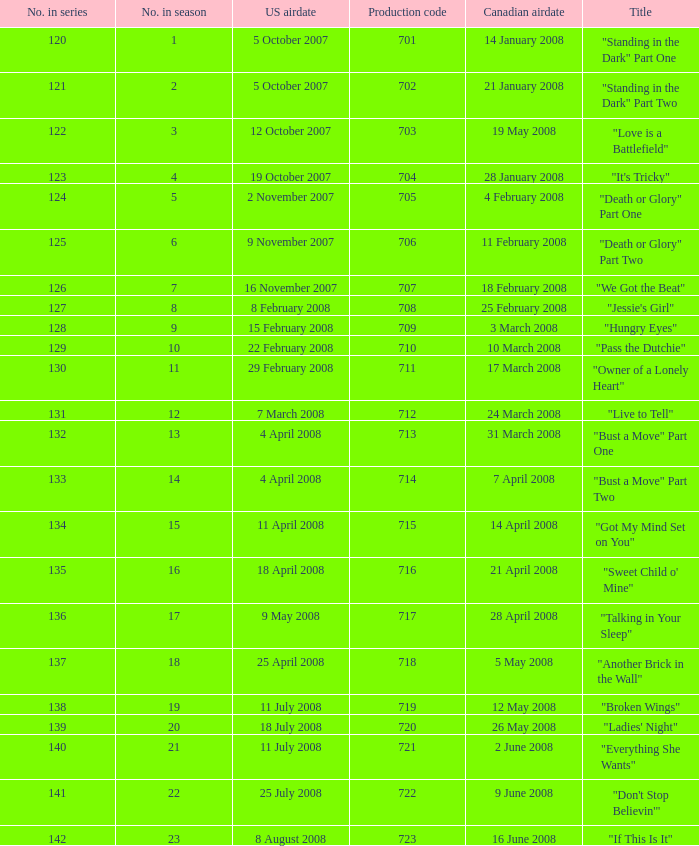The canadian airdate of 17 march 2008 had how many numbers in the season? 1.0. Would you be able to parse every entry in this table? {'header': ['No. in series', 'No. in season', 'US airdate', 'Production code', 'Canadian airdate', 'Title'], 'rows': [['120', '1', '5 October 2007', '701', '14 January 2008', '"Standing in the Dark" Part One'], ['121', '2', '5 October 2007', '702', '21 January 2008', '"Standing in the Dark" Part Two'], ['122', '3', '12 October 2007', '703', '19 May 2008', '"Love is a Battlefield"'], ['123', '4', '19 October 2007', '704', '28 January 2008', '"It\'s Tricky"'], ['124', '5', '2 November 2007', '705', '4 February 2008', '"Death or Glory" Part One'], ['125', '6', '9 November 2007', '706', '11 February 2008', '"Death or Glory" Part Two'], ['126', '7', '16 November 2007', '707', '18 February 2008', '"We Got the Beat"'], ['127', '8', '8 February 2008', '708', '25 February 2008', '"Jessie\'s Girl"'], ['128', '9', '15 February 2008', '709', '3 March 2008', '"Hungry Eyes"'], ['129', '10', '22 February 2008', '710', '10 March 2008', '"Pass the Dutchie"'], ['130', '11', '29 February 2008', '711', '17 March 2008', '"Owner of a Lonely Heart"'], ['131', '12', '7 March 2008', '712', '24 March 2008', '"Live to Tell"'], ['132', '13', '4 April 2008', '713', '31 March 2008', '"Bust a Move" Part One'], ['133', '14', '4 April 2008', '714', '7 April 2008', '"Bust a Move" Part Two'], ['134', '15', '11 April 2008', '715', '14 April 2008', '"Got My Mind Set on You"'], ['135', '16', '18 April 2008', '716', '21 April 2008', '"Sweet Child o\' Mine"'], ['136', '17', '9 May 2008', '717', '28 April 2008', '"Talking in Your Sleep"'], ['137', '18', '25 April 2008', '718', '5 May 2008', '"Another Brick in the Wall"'], ['138', '19', '11 July 2008', '719', '12 May 2008', '"Broken Wings"'], ['139', '20', '18 July 2008', '720', '26 May 2008', '"Ladies\' Night"'], ['140', '21', '11 July 2008', '721', '2 June 2008', '"Everything She Wants"'], ['141', '22', '25 July 2008', '722', '9 June 2008', '"Don\'t Stop Believin\'"'], ['142', '23', '8 August 2008', '723', '16 June 2008', '"If This Is It"']]} 